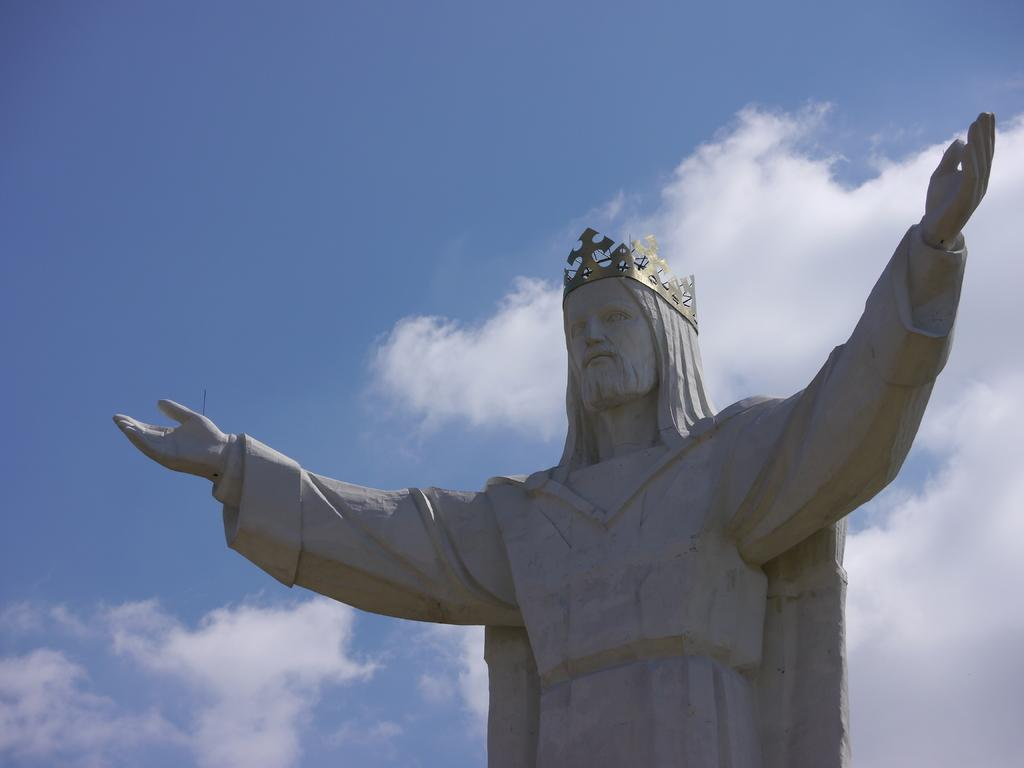What is the main subject in the image? There is a statue in the image. What can be seen in the background of the image? The sky is visible in the background of the image. What is the condition of the sky in the image? Clouds are present in the sky. What type of peace is depicted in the image? There is no depiction of peace in the image; it features a statue and clouds in the sky. 